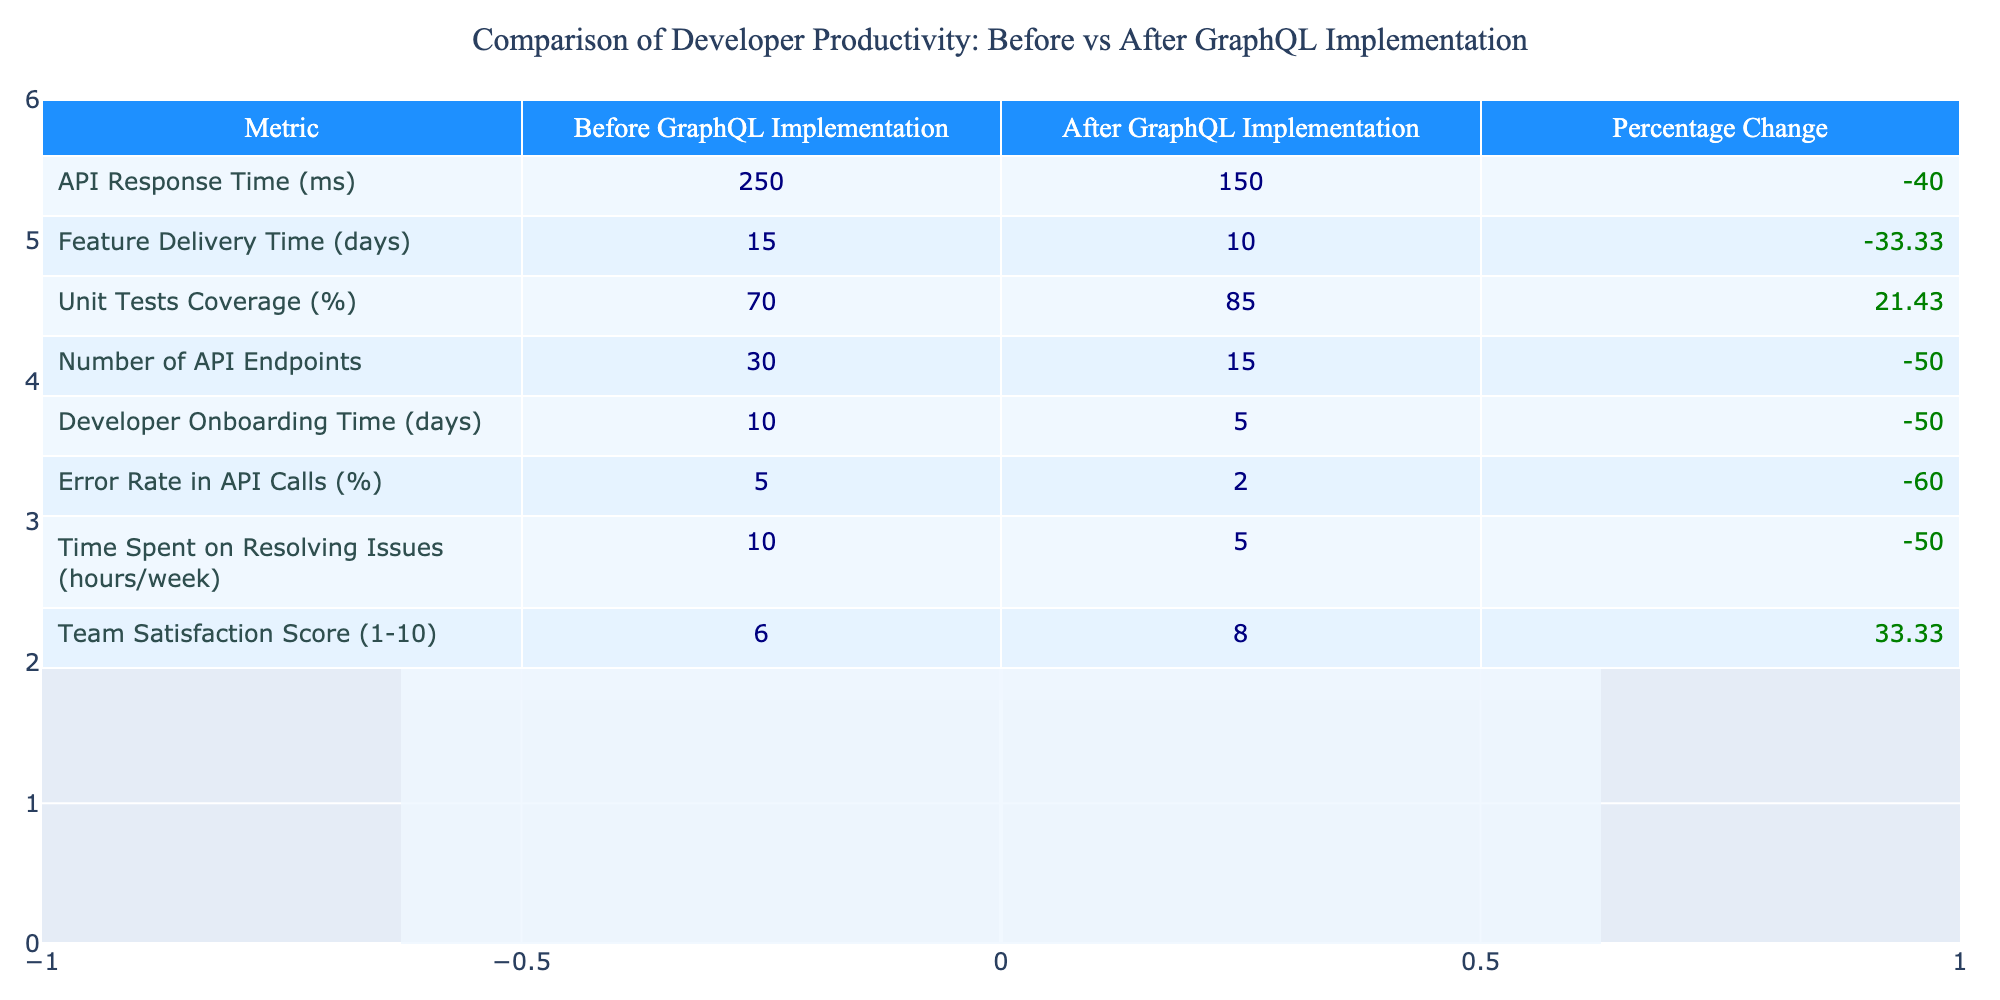What was the API response time before GraphQL implementation? The table indicates that the API response time before implementation was 250 milliseconds. This value is found directly in the "Before GraphQL Implementation" column for the "API Response Time" metric.
Answer: 250 ms What is the percentage change in unit test coverage after implementing GraphQL? The unit test coverage increased from 70% to 85%, leading to a percentage change calculated as ((85 - 70) / 70) * 100 = 21.43%. This percentage is provided in the table under the corresponding metric.
Answer: 21.43% Did the developer onboarding time increase or decrease after GraphQL implementation? The onboarding time decreased from 10 days to 5 days after the implementation. Since 5 is less than 10, we can conclude that there was a decrease.
Answer: Decrease What product metric had the most significant improvement after GraphQL implementation? The largest improvement is noted in the error rate in API calls, which went from 5% to 2%, resulting in a percentage change of -60%. This is the highest percentage change in the table.
Answer: Error Rate in API Calls What is the average percentage change for all the metrics listed in the table? To find the average percentage change, we sum the percentage changes: -40 + -33.33 + 21.43 + -50 + -50 + -60 + -50 + 33.33 = -169.57. Dividing by the number of metrics (8) gives an average of -21.19%.
Answer: -21.19% What was the team satisfaction score after implementing GraphQL? According to the table, the team satisfaction score after the implementation was 8. This figure is indicated directly in the "After GraphQL Implementation" column for the "Team Satisfaction Score" row.
Answer: 8 Was there an increase in the number of API endpoints after implementing GraphQL? No, there was a decrease in the number of API endpoints, going from 30 before to 15 after the implementation. This is evident as 15 is less than 30.
Answer: No What is the change in feature delivery time after GraphQL implementation? The delivery time changed from 15 days to 10 days, resulting in a decrease of 5 days. This can be calculated by subtracting the "After GraphQL Implementation" value from the "Before GraphQL Implementation" value.
Answer: 5 days decrease 